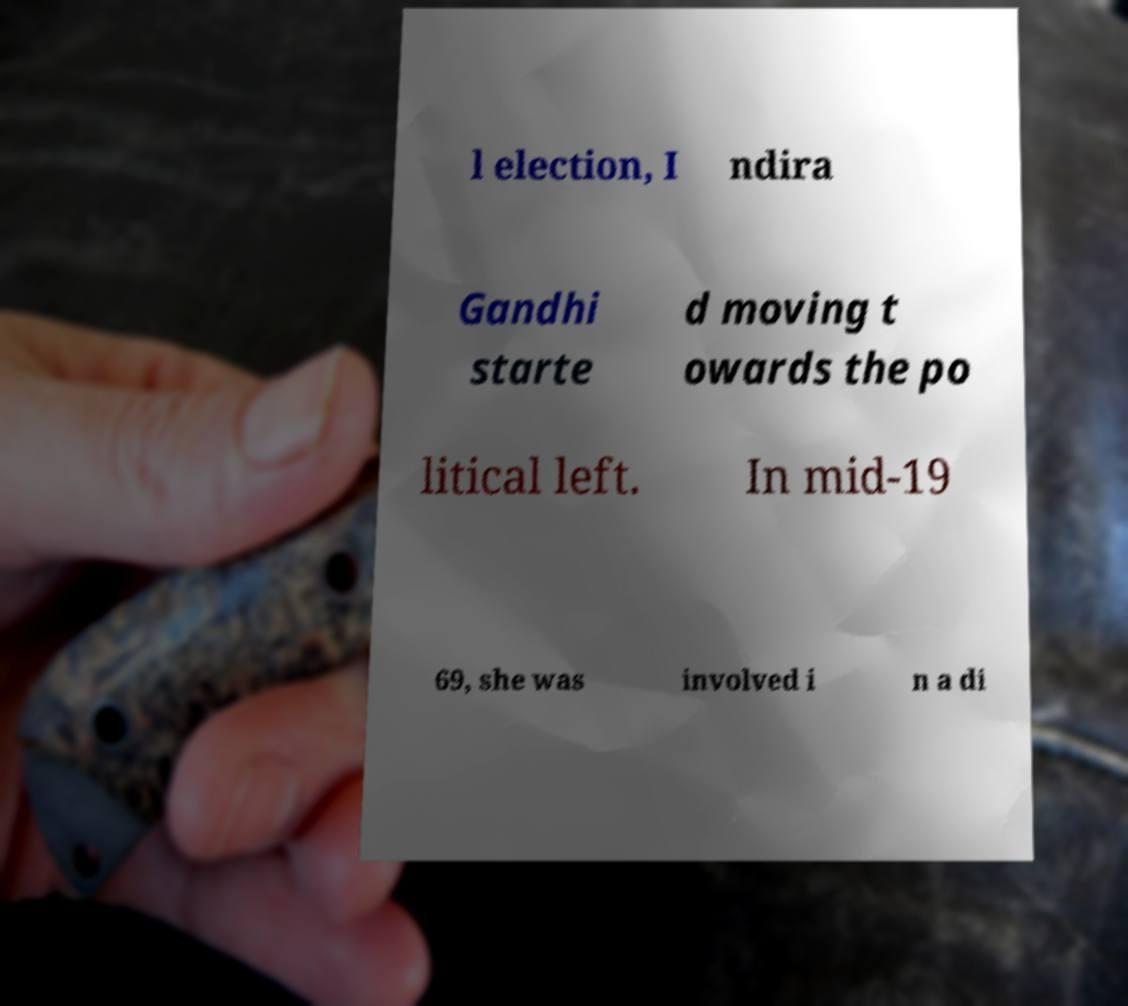I need the written content from this picture converted into text. Can you do that? l election, I ndira Gandhi starte d moving t owards the po litical left. In mid-19 69, she was involved i n a di 